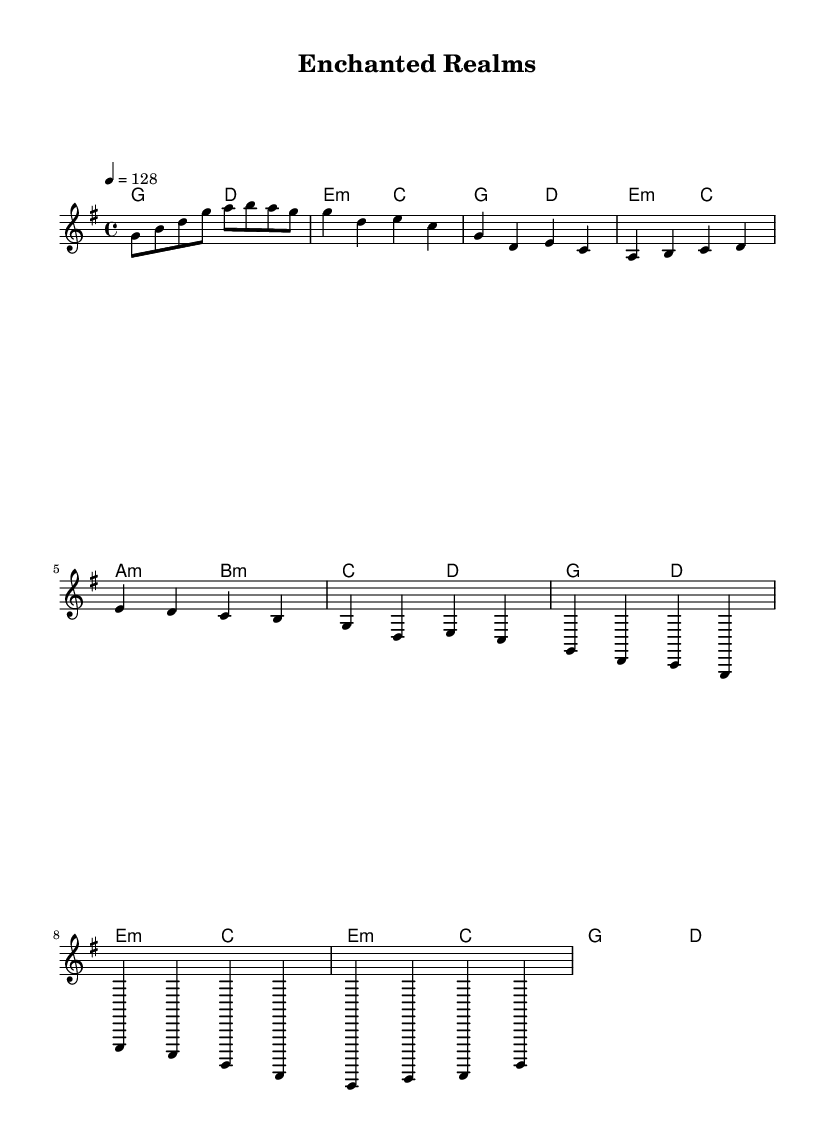What is the key signature of this music? The key signature is G major, which has one sharp (F#). This can be identified by looking at the signature at the beginning of the staff.
Answer: G major What is the time signature of the music? The time signature is 4/4, indicated at the beginning of the score. This means there are four beats in each measure and a quarter note receives one beat.
Answer: 4/4 What is the tempo marking for the piece? The tempo marking is 128 beats per minute, which is noted after the \tempo command. This indicates how fast the music should be played.
Answer: 128 How many measures are there in the verse section? The verse section consists of two measures, as indicated by the notation following the introductory melody. Counting the notation lines confirms there are two distinct measures.
Answer: 2 What types of chords are used in the pre-chorus? The pre-chorus contains minor chords (a minor and b minor) followed by a major chord (c major and d major), which enhance the emotional contrast and lead into the chorus. Visualizing the chord changes in this section demonstrates their quality.
Answer: Minor and Major What is the structure of this piece following the traditional K-Pop format? The structure follows an Intro, Verse, Pre-Chorus, Chorus, and Bridge, typical of K-Pop songs, which usually build to a catchy chorus after a series of verses and pre-choruses. This can be seen from both the section names and their order in the sheet music.
Answer: Intro, Verse, Pre-Chorus, Chorus, Bridge 